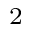Convert formula to latex. <formula><loc_0><loc_0><loc_500><loc_500>_ { 2 }</formula> 